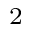Convert formula to latex. <formula><loc_0><loc_0><loc_500><loc_500>_ { 2 }</formula> 